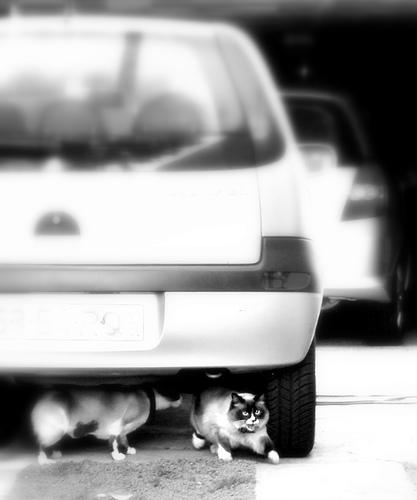How is the cat feeling?
Quick response, please. Scared. What is the license plate?
Short answer required. Blank. What is the focus of this image?
Give a very brief answer. Cat. 